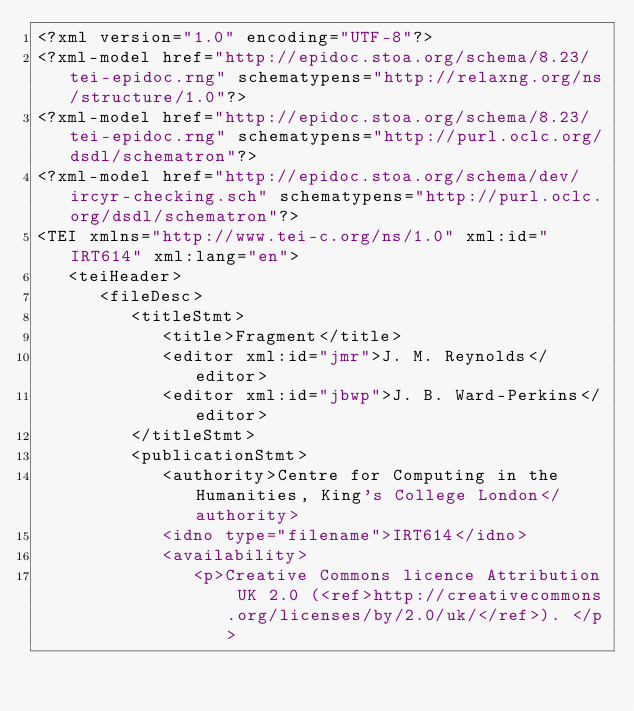<code> <loc_0><loc_0><loc_500><loc_500><_XML_><?xml version="1.0" encoding="UTF-8"?>
<?xml-model href="http://epidoc.stoa.org/schema/8.23/tei-epidoc.rng" schematypens="http://relaxng.org/ns/structure/1.0"?><?xml-model href="http://epidoc.stoa.org/schema/8.23/tei-epidoc.rng" schematypens="http://purl.oclc.org/dsdl/schematron"?><?xml-model href="http://epidoc.stoa.org/schema/dev/ircyr-checking.sch" schematypens="http://purl.oclc.org/dsdl/schematron"?><TEI xmlns="http://www.tei-c.org/ns/1.0" xml:id="IRT614" xml:lang="en">
   <teiHeader>
      <fileDesc>
         <titleStmt>
            <title>Fragment</title>
            <editor xml:id="jmr">J. M. Reynolds</editor>
            <editor xml:id="jbwp">J. B. Ward-Perkins</editor>
         </titleStmt>
         <publicationStmt>
            <authority>Centre for Computing in the Humanities, King's College London</authority>
            <idno type="filename">IRT614</idno>
            <availability>
               <p>Creative Commons licence Attribution UK 2.0 (<ref>http://creativecommons.org/licenses/by/2.0/uk/</ref>). </p></code> 